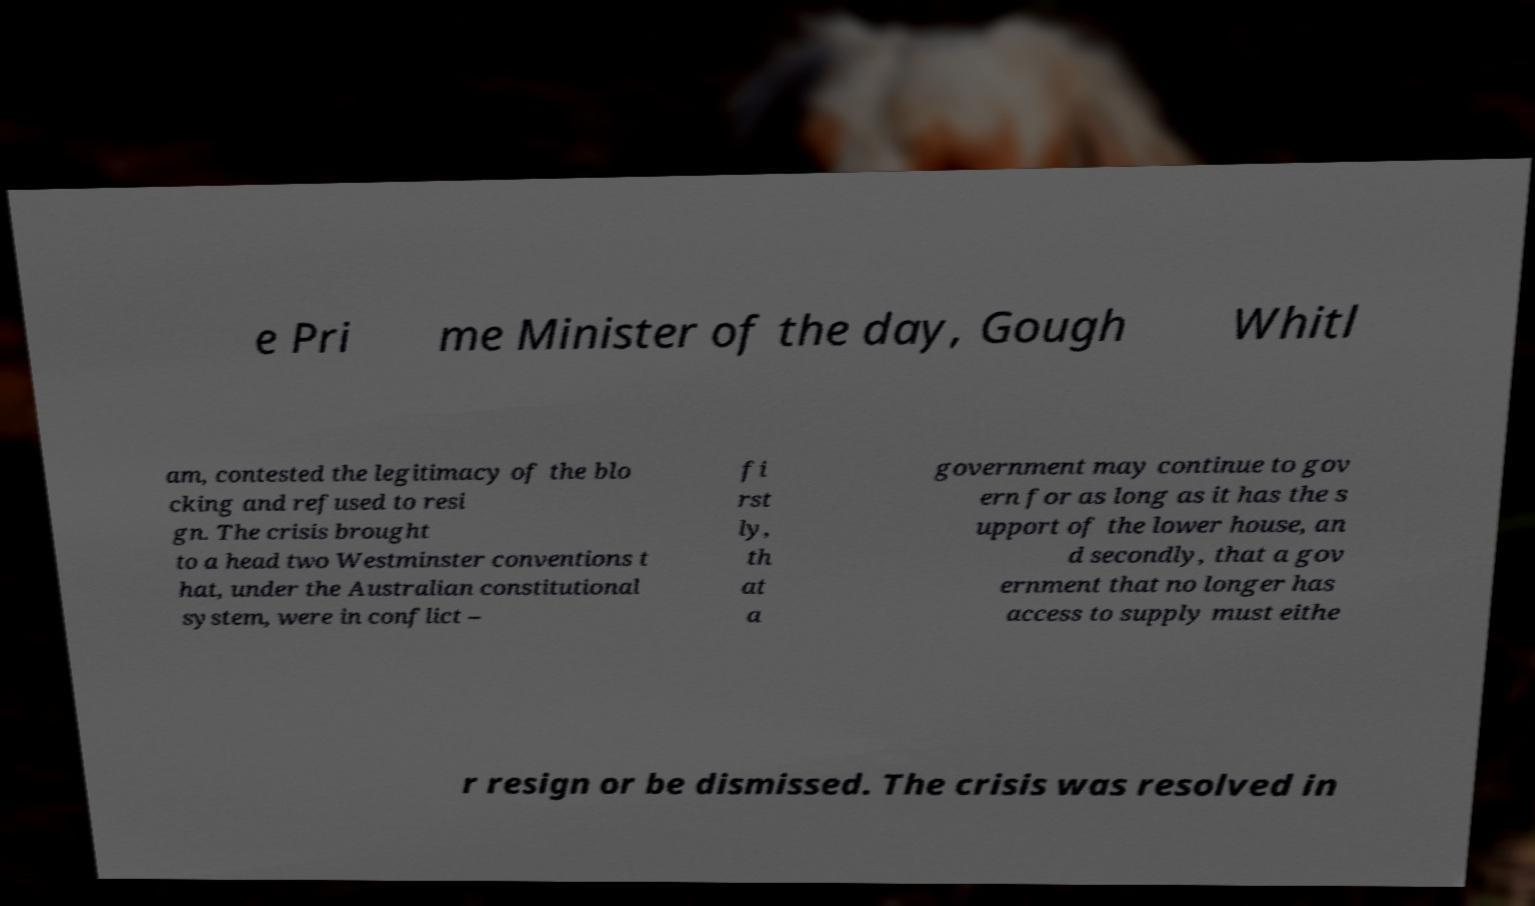For documentation purposes, I need the text within this image transcribed. Could you provide that? e Pri me Minister of the day, Gough Whitl am, contested the legitimacy of the blo cking and refused to resi gn. The crisis brought to a head two Westminster conventions t hat, under the Australian constitutional system, were in conflict – fi rst ly, th at a government may continue to gov ern for as long as it has the s upport of the lower house, an d secondly, that a gov ernment that no longer has access to supply must eithe r resign or be dismissed. The crisis was resolved in 